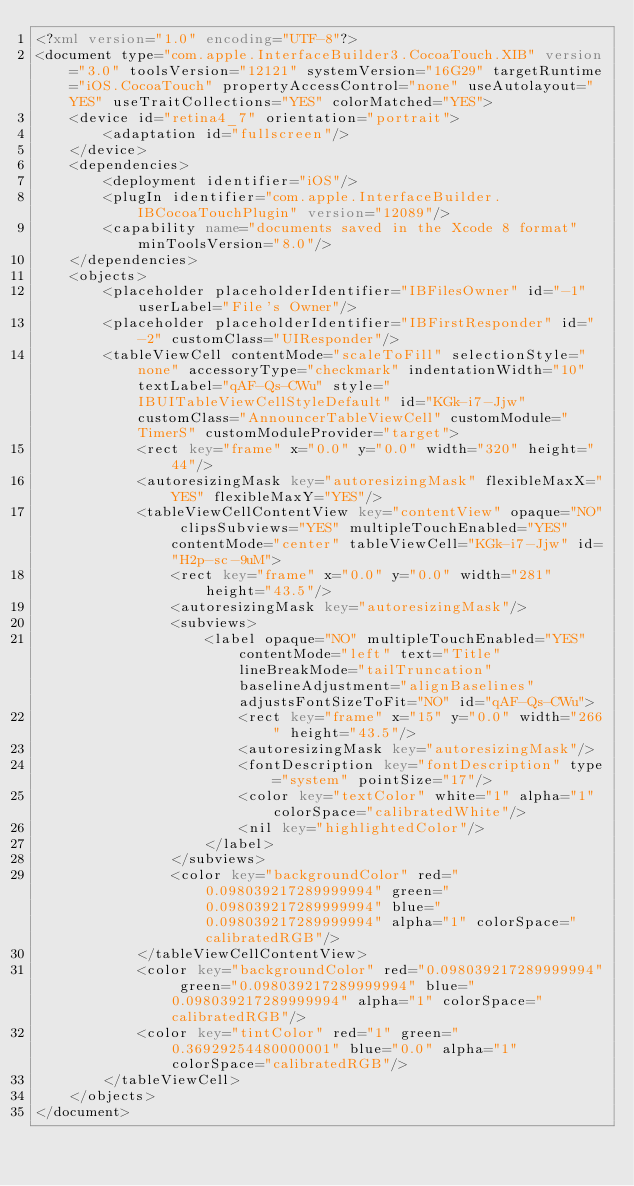Convert code to text. <code><loc_0><loc_0><loc_500><loc_500><_XML_><?xml version="1.0" encoding="UTF-8"?>
<document type="com.apple.InterfaceBuilder3.CocoaTouch.XIB" version="3.0" toolsVersion="12121" systemVersion="16G29" targetRuntime="iOS.CocoaTouch" propertyAccessControl="none" useAutolayout="YES" useTraitCollections="YES" colorMatched="YES">
    <device id="retina4_7" orientation="portrait">
        <adaptation id="fullscreen"/>
    </device>
    <dependencies>
        <deployment identifier="iOS"/>
        <plugIn identifier="com.apple.InterfaceBuilder.IBCocoaTouchPlugin" version="12089"/>
        <capability name="documents saved in the Xcode 8 format" minToolsVersion="8.0"/>
    </dependencies>
    <objects>
        <placeholder placeholderIdentifier="IBFilesOwner" id="-1" userLabel="File's Owner"/>
        <placeholder placeholderIdentifier="IBFirstResponder" id="-2" customClass="UIResponder"/>
        <tableViewCell contentMode="scaleToFill" selectionStyle="none" accessoryType="checkmark" indentationWidth="10" textLabel="qAF-Qs-CWu" style="IBUITableViewCellStyleDefault" id="KGk-i7-Jjw" customClass="AnnouncerTableViewCell" customModule="TimerS" customModuleProvider="target">
            <rect key="frame" x="0.0" y="0.0" width="320" height="44"/>
            <autoresizingMask key="autoresizingMask" flexibleMaxX="YES" flexibleMaxY="YES"/>
            <tableViewCellContentView key="contentView" opaque="NO" clipsSubviews="YES" multipleTouchEnabled="YES" contentMode="center" tableViewCell="KGk-i7-Jjw" id="H2p-sc-9uM">
                <rect key="frame" x="0.0" y="0.0" width="281" height="43.5"/>
                <autoresizingMask key="autoresizingMask"/>
                <subviews>
                    <label opaque="NO" multipleTouchEnabled="YES" contentMode="left" text="Title" lineBreakMode="tailTruncation" baselineAdjustment="alignBaselines" adjustsFontSizeToFit="NO" id="qAF-Qs-CWu">
                        <rect key="frame" x="15" y="0.0" width="266" height="43.5"/>
                        <autoresizingMask key="autoresizingMask"/>
                        <fontDescription key="fontDescription" type="system" pointSize="17"/>
                        <color key="textColor" white="1" alpha="1" colorSpace="calibratedWhite"/>
                        <nil key="highlightedColor"/>
                    </label>
                </subviews>
                <color key="backgroundColor" red="0.098039217289999994" green="0.098039217289999994" blue="0.098039217289999994" alpha="1" colorSpace="calibratedRGB"/>
            </tableViewCellContentView>
            <color key="backgroundColor" red="0.098039217289999994" green="0.098039217289999994" blue="0.098039217289999994" alpha="1" colorSpace="calibratedRGB"/>
            <color key="tintColor" red="1" green="0.36929254480000001" blue="0.0" alpha="1" colorSpace="calibratedRGB"/>
        </tableViewCell>
    </objects>
</document>
</code> 